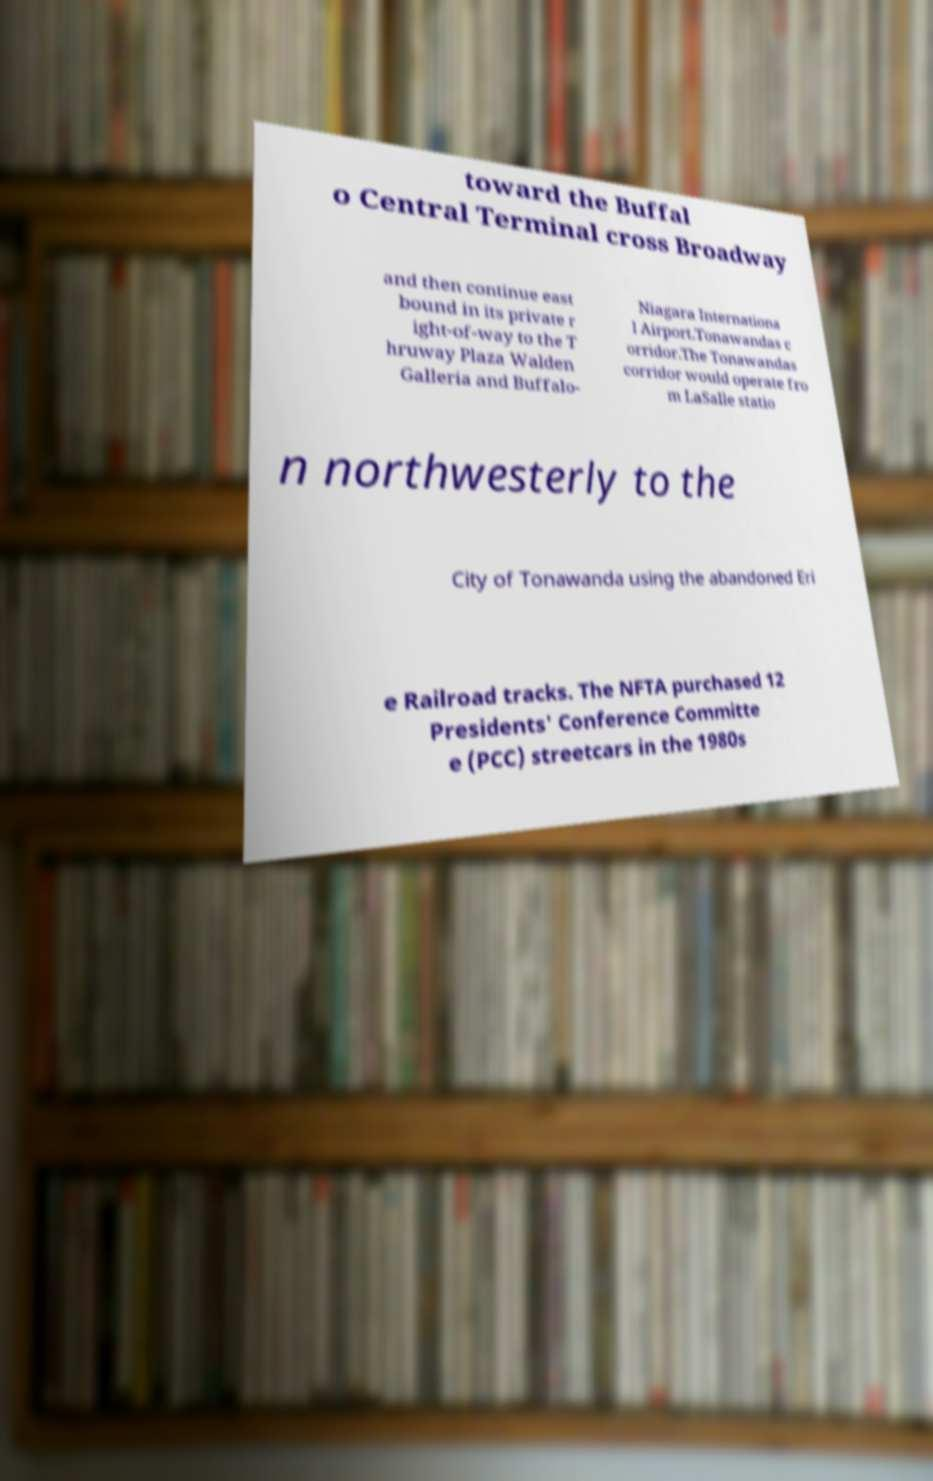Can you accurately transcribe the text from the provided image for me? toward the Buffal o Central Terminal cross Broadway and then continue east bound in its private r ight-of-way to the T hruway Plaza Walden Galleria and Buffalo- Niagara Internationa l Airport.Tonawandas c orridor.The Tonawandas corridor would operate fro m LaSalle statio n northwesterly to the City of Tonawanda using the abandoned Eri e Railroad tracks. The NFTA purchased 12 Presidents' Conference Committe e (PCC) streetcars in the 1980s 